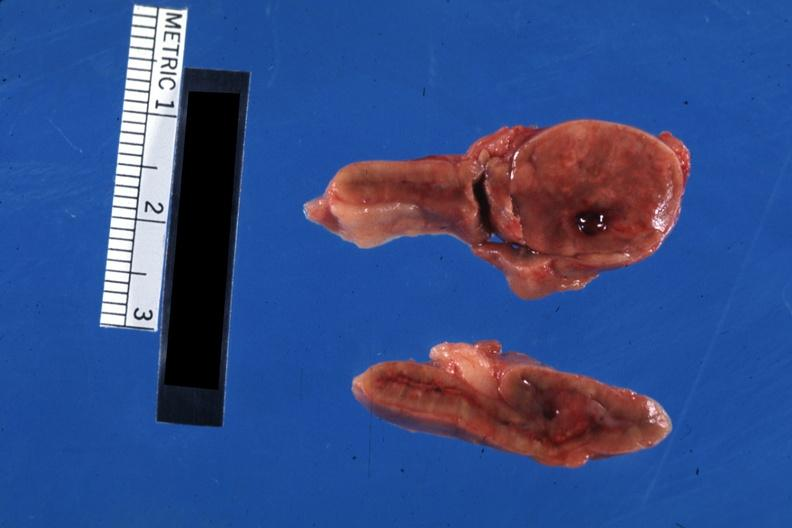s endocrine present?
Answer the question using a single word or phrase. Yes 